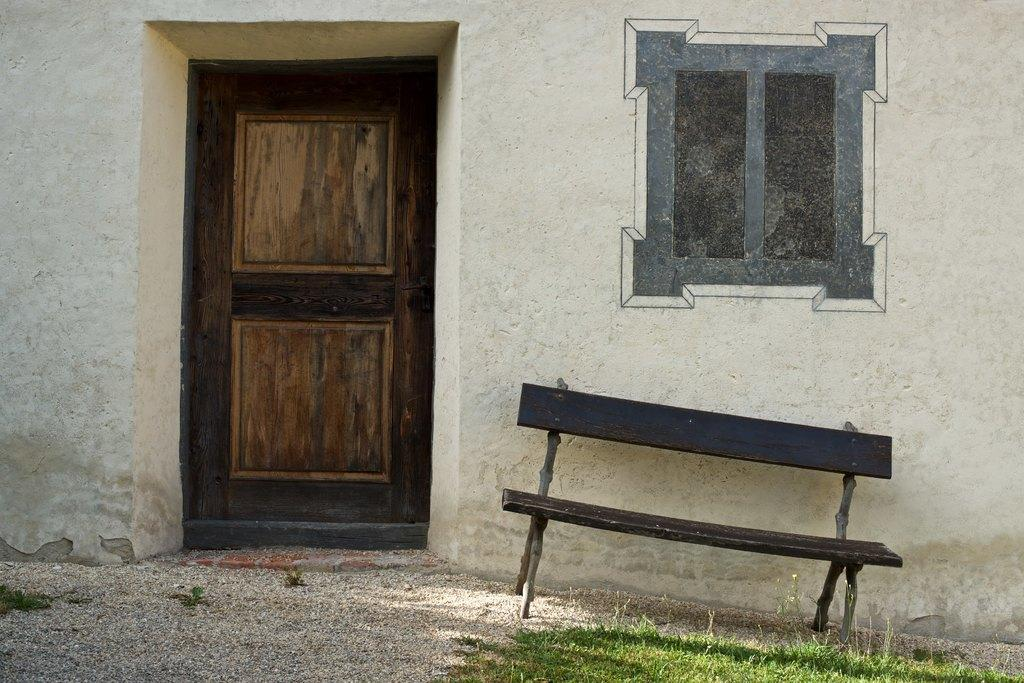What type of structure can be seen in the image? There is a wall in the image. Is there an entrance visible in the image? Yes, there is a door in the image. What type of seating is present in the image? There is a bench in the image. What is the surface of the path like in the image? Grass is present on the path in the image. How many tickets are needed to access the quartz on the path in the image? There is no quartz or ticket present in the image. What type of fingerprint can be seen on the door in the image? There is no fingerprint visible on the door in the image. 